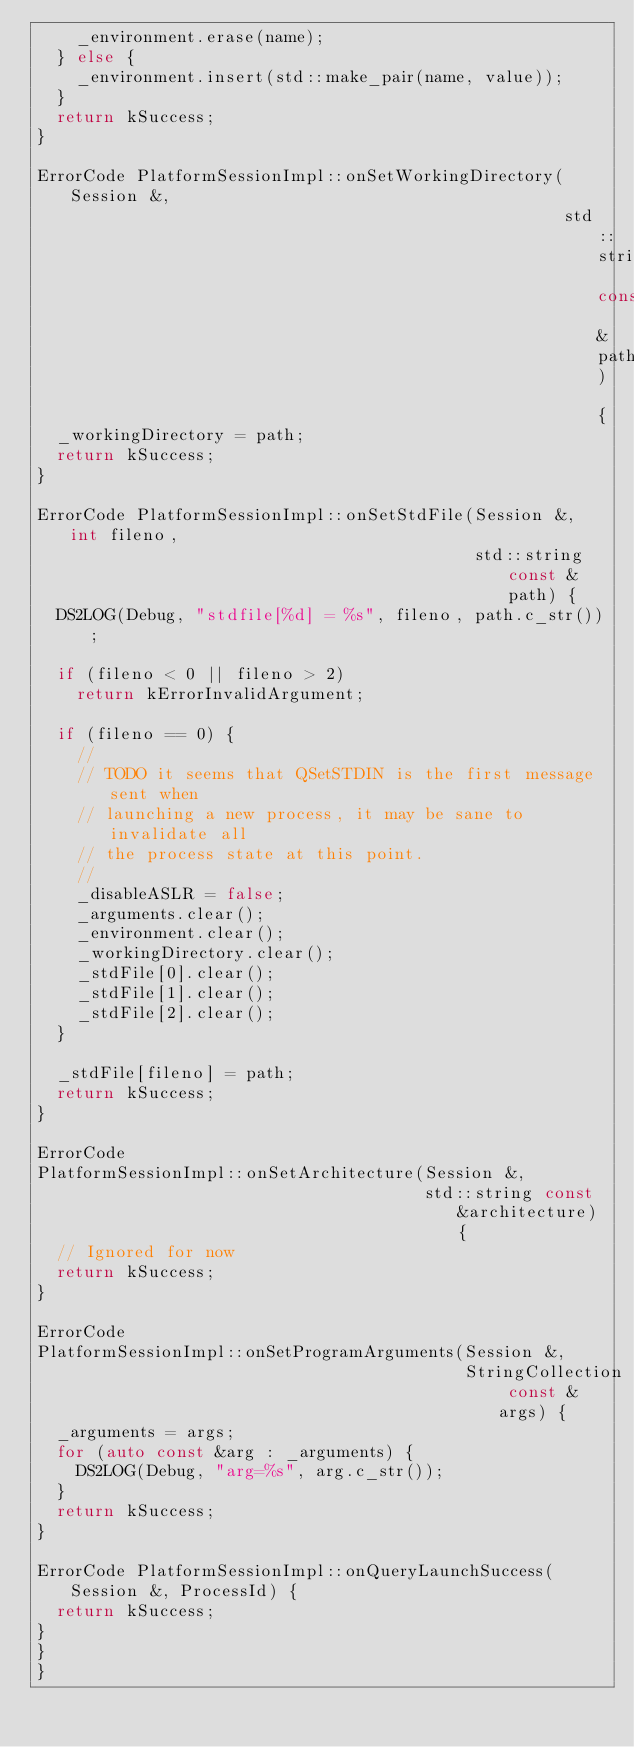Convert code to text. <code><loc_0><loc_0><loc_500><loc_500><_C++_>    _environment.erase(name);
  } else {
    _environment.insert(std::make_pair(name, value));
  }
  return kSuccess;
}

ErrorCode PlatformSessionImpl::onSetWorkingDirectory(Session &,
                                                     std::string const &path) {
  _workingDirectory = path;
  return kSuccess;
}

ErrorCode PlatformSessionImpl::onSetStdFile(Session &, int fileno,
                                            std::string const &path) {
  DS2LOG(Debug, "stdfile[%d] = %s", fileno, path.c_str());

  if (fileno < 0 || fileno > 2)
    return kErrorInvalidArgument;

  if (fileno == 0) {
    //
    // TODO it seems that QSetSTDIN is the first message sent when
    // launching a new process, it may be sane to invalidate all
    // the process state at this point.
    //
    _disableASLR = false;
    _arguments.clear();
    _environment.clear();
    _workingDirectory.clear();
    _stdFile[0].clear();
    _stdFile[1].clear();
    _stdFile[2].clear();
  }

  _stdFile[fileno] = path;
  return kSuccess;
}

ErrorCode
PlatformSessionImpl::onSetArchitecture(Session &,
                                       std::string const &architecture) {
  // Ignored for now
  return kSuccess;
}

ErrorCode
PlatformSessionImpl::onSetProgramArguments(Session &,
                                           StringCollection const &args) {
  _arguments = args;
  for (auto const &arg : _arguments) {
    DS2LOG(Debug, "arg=%s", arg.c_str());
  }
  return kSuccess;
}

ErrorCode PlatformSessionImpl::onQueryLaunchSuccess(Session &, ProcessId) {
  return kSuccess;
}
}
}
</code> 